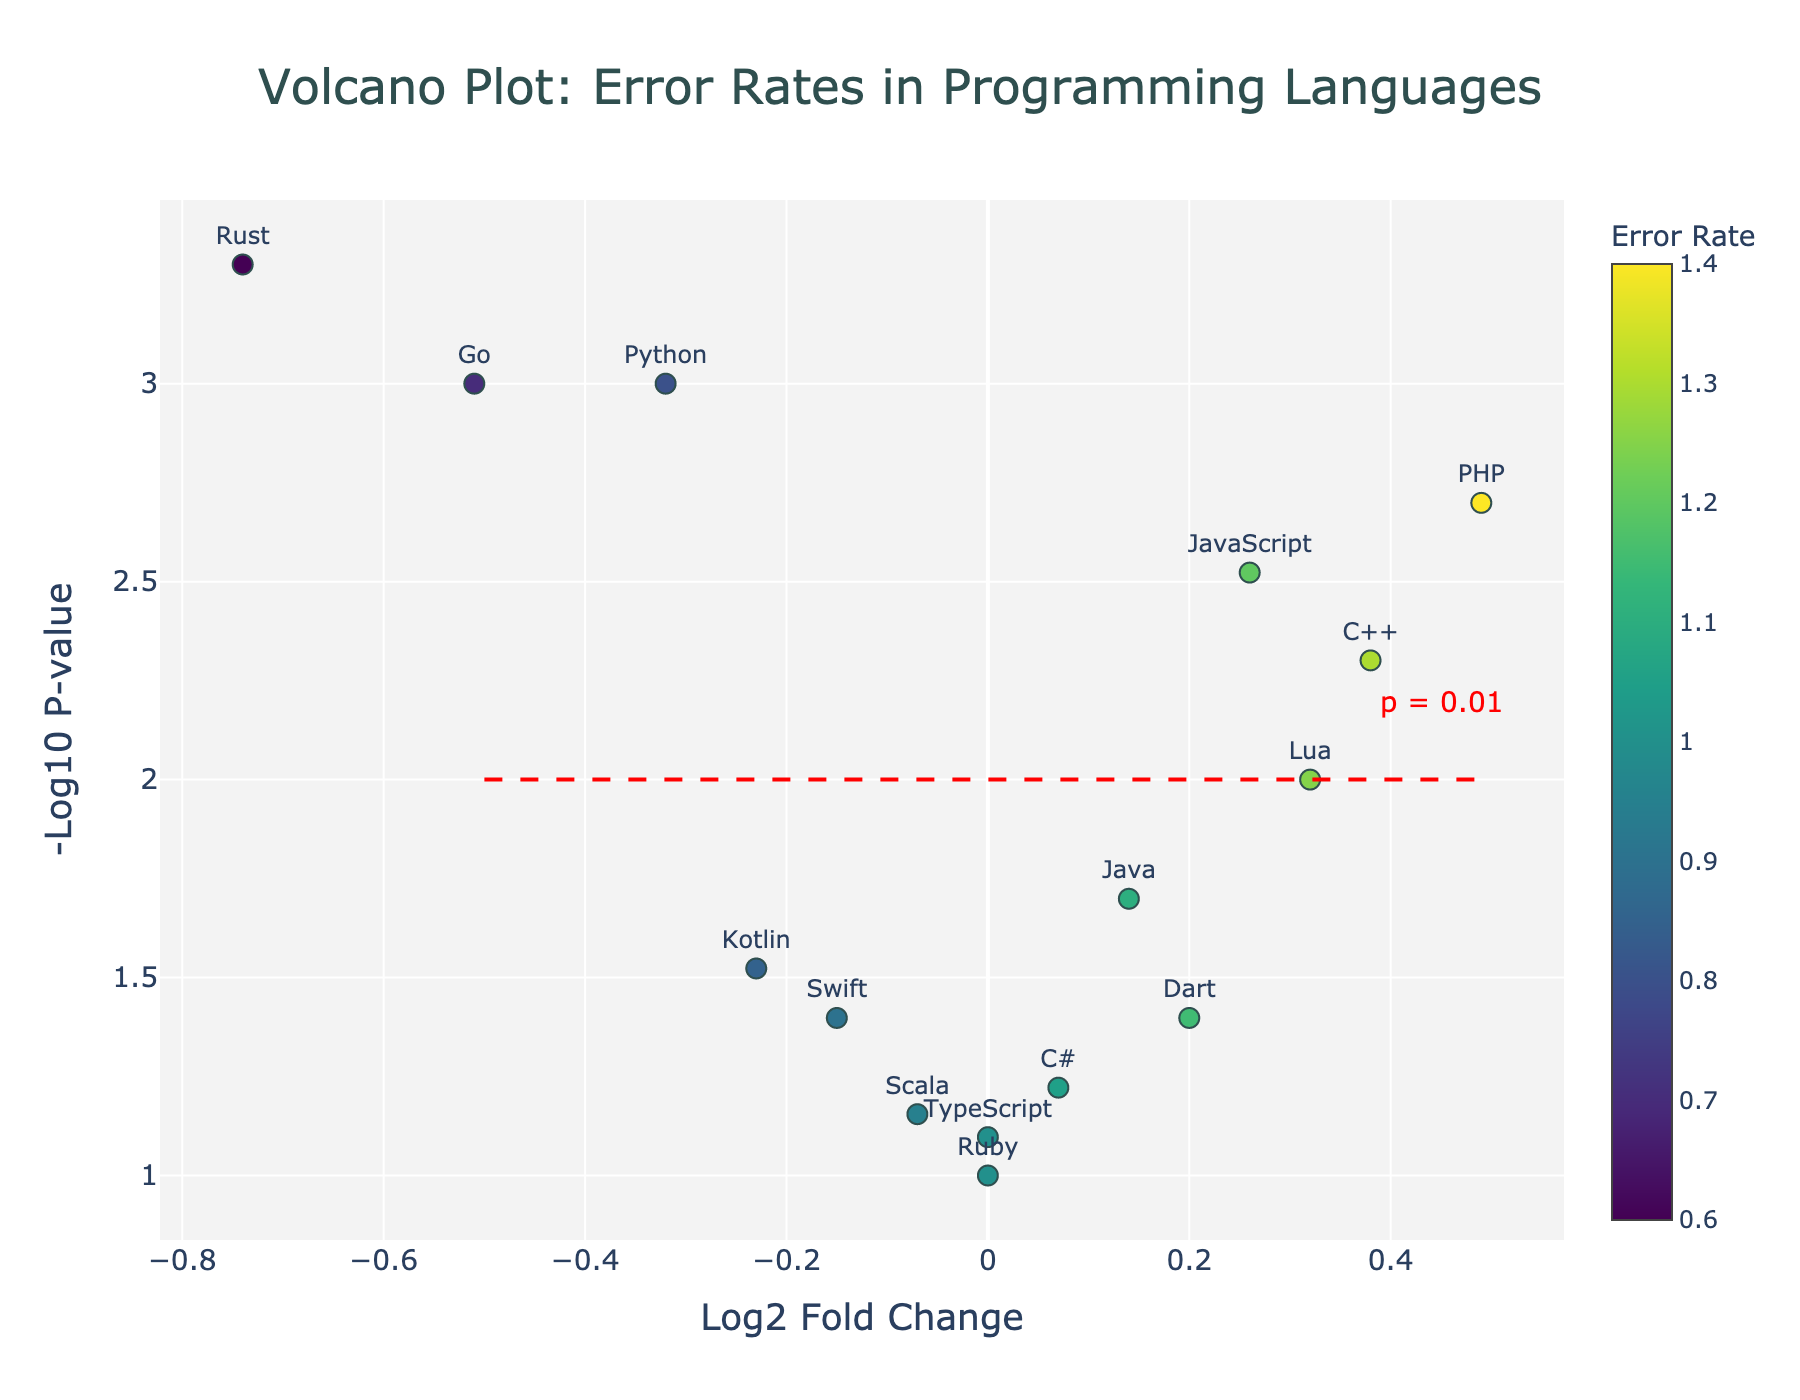What is the title of the plot? The title of the plot is displayed at the top, it reads "Volcano Plot: Error Rates in Programming Languages".
Answer: Volcano Plot: Error Rates in Programming Languages Which programming language has the highest -log10(p-value)? The highest -log10(p-value) corresponds to the highest point on the y-axis. According to the plot, Rust has the highest -log10(p-value).
Answer: Rust How are the programming languages color-coded in this plot? The programming languages are colored based on the error rate, with a colorscale provided to illustrate the mapping, ranging from low to high values.
Answer: By error rate Which programming language has the highest error rate? The highest error rate can be found by looking at the color scale on the right and identifying the data point with the darkest color. PHP has the darkest color, indicating the highest error rate.
Answer: PHP What is the significance threshold line on the plot, and what p-value does it correspond to? The significance threshold is represented by a dashed red line at y = 2, which corresponds to a p-value of 0.01.
Answer: y = 2, p = 0.01 How many languages have a positive log2 fold change? Positive log2 fold change values are found to the right of the y-axis (positive x-axis region). Counting the points on the right, we get six languages.
Answer: Six Which language has the lowest error rate with a significant p-value? To find the programming language with the lowest error rate and significant p-value (above the red line at y = 2), we look for the language with the lowest y-axis position above the threshold. Rust has the lowest error rate with a highly significant p-value.
Answer: Rust What's the log2 fold change for Python, and how does it relate to zero? According to the hover information or the position on the x-axis, Python's log2 fold change is -0.32. This is below zero, indicating a negative log2 fold change.
Answer: -0.32, below zero Which language has the most extreme (highest magnitude) log2 fold change? The most extreme log2 fold change can be found by identifying the point farthest from zero on the x-axis. Rust has the most extreme log2 fold change at -0.74.
Answer: Rust What is the error rate range in the plot? The error rate range spans from the lightest color (lowest) to the darkest color (highest) on the color scale bar. The lowest error rate is 0.6 (Rust), and the highest is 1.4 (PHP), giving a range of 0.8.
Answer: 0.6 to 1.4 